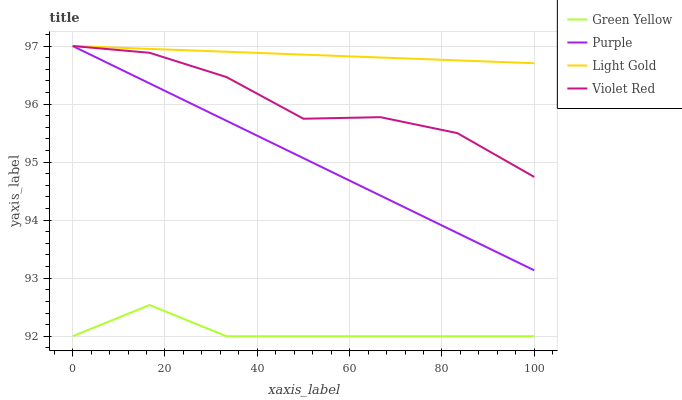Does Green Yellow have the minimum area under the curve?
Answer yes or no. Yes. Does Light Gold have the maximum area under the curve?
Answer yes or no. Yes. Does Violet Red have the minimum area under the curve?
Answer yes or no. No. Does Violet Red have the maximum area under the curve?
Answer yes or no. No. Is Purple the smoothest?
Answer yes or no. Yes. Is Violet Red the roughest?
Answer yes or no. Yes. Is Green Yellow the smoothest?
Answer yes or no. No. Is Green Yellow the roughest?
Answer yes or no. No. Does Green Yellow have the lowest value?
Answer yes or no. Yes. Does Violet Red have the lowest value?
Answer yes or no. No. Does Light Gold have the highest value?
Answer yes or no. Yes. Does Green Yellow have the highest value?
Answer yes or no. No. Is Green Yellow less than Purple?
Answer yes or no. Yes. Is Violet Red greater than Green Yellow?
Answer yes or no. Yes. Does Violet Red intersect Purple?
Answer yes or no. Yes. Is Violet Red less than Purple?
Answer yes or no. No. Is Violet Red greater than Purple?
Answer yes or no. No. Does Green Yellow intersect Purple?
Answer yes or no. No. 